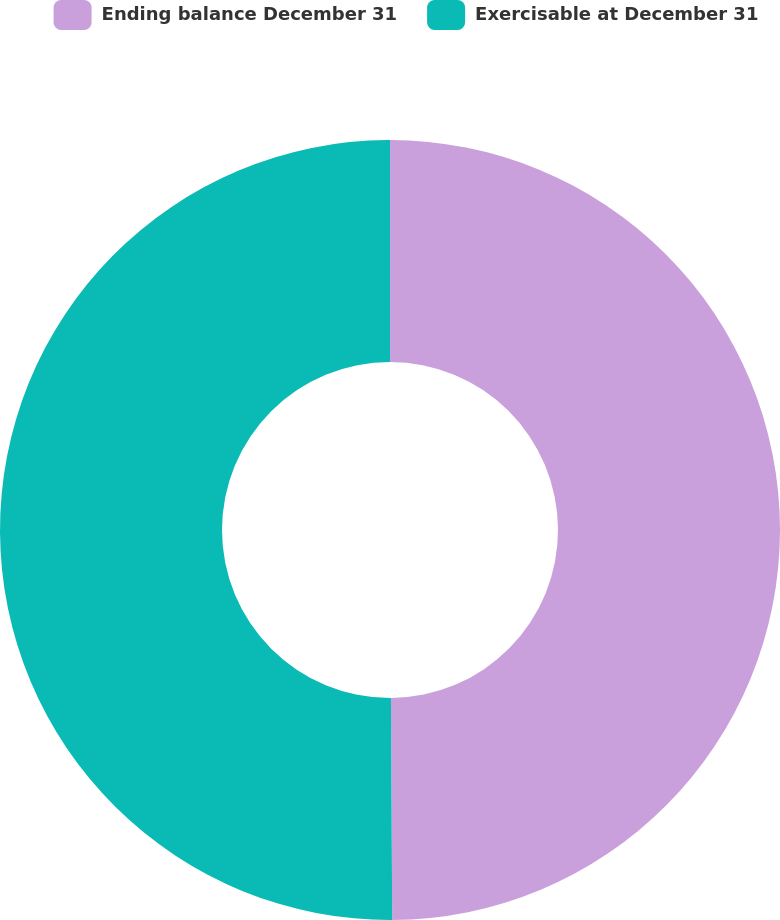<chart> <loc_0><loc_0><loc_500><loc_500><pie_chart><fcel>Ending balance December 31<fcel>Exercisable at December 31<nl><fcel>49.91%<fcel>50.09%<nl></chart> 